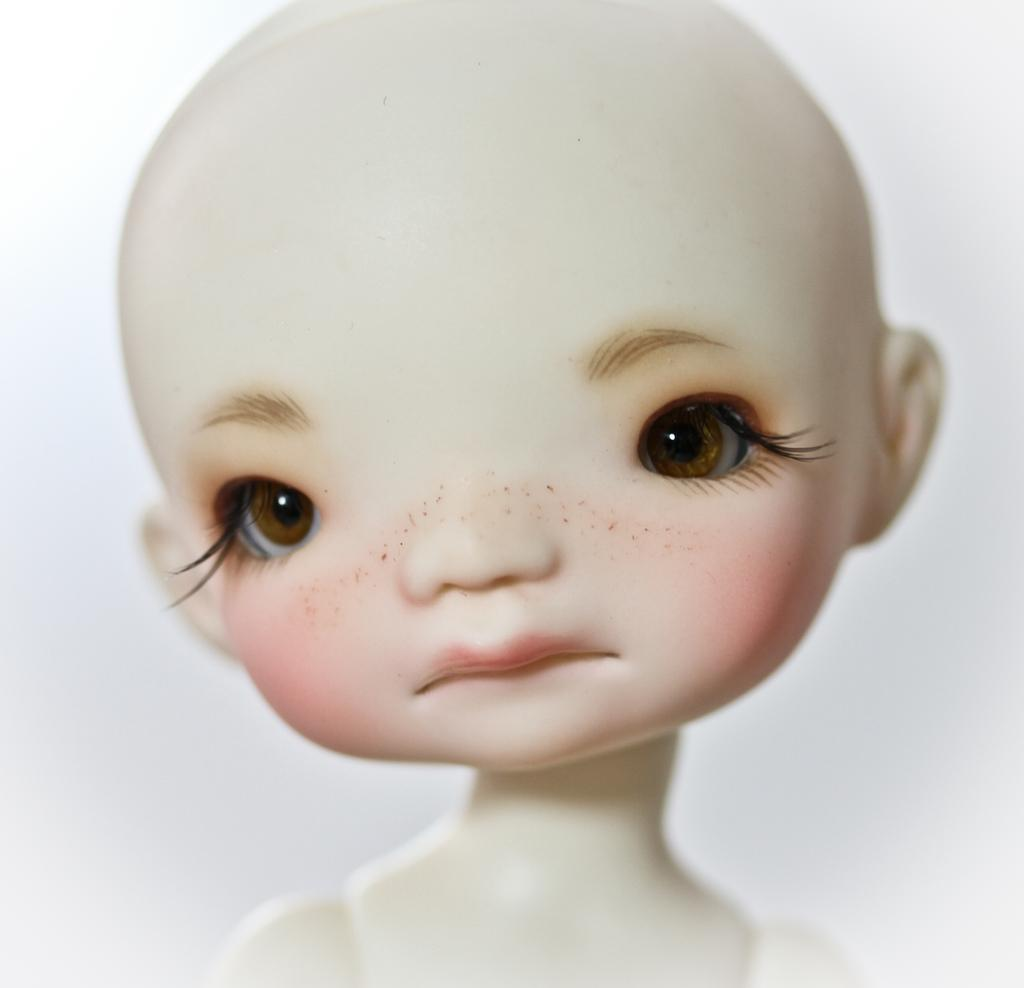What is the main subject of the image? The main subject of the image is a baby doll. Where is the baby doll located in the image? The baby doll is in the center of the image. What color is the baby doll? The baby doll is white in color. What type of teaching method is being demonstrated with the baby doll in the image? There is no teaching method being demonstrated in the image; it simply features a white baby doll in the center. What is the condition of the baby doll in the image? The provided facts do not mention the condition of the baby doll, only its color and location. 